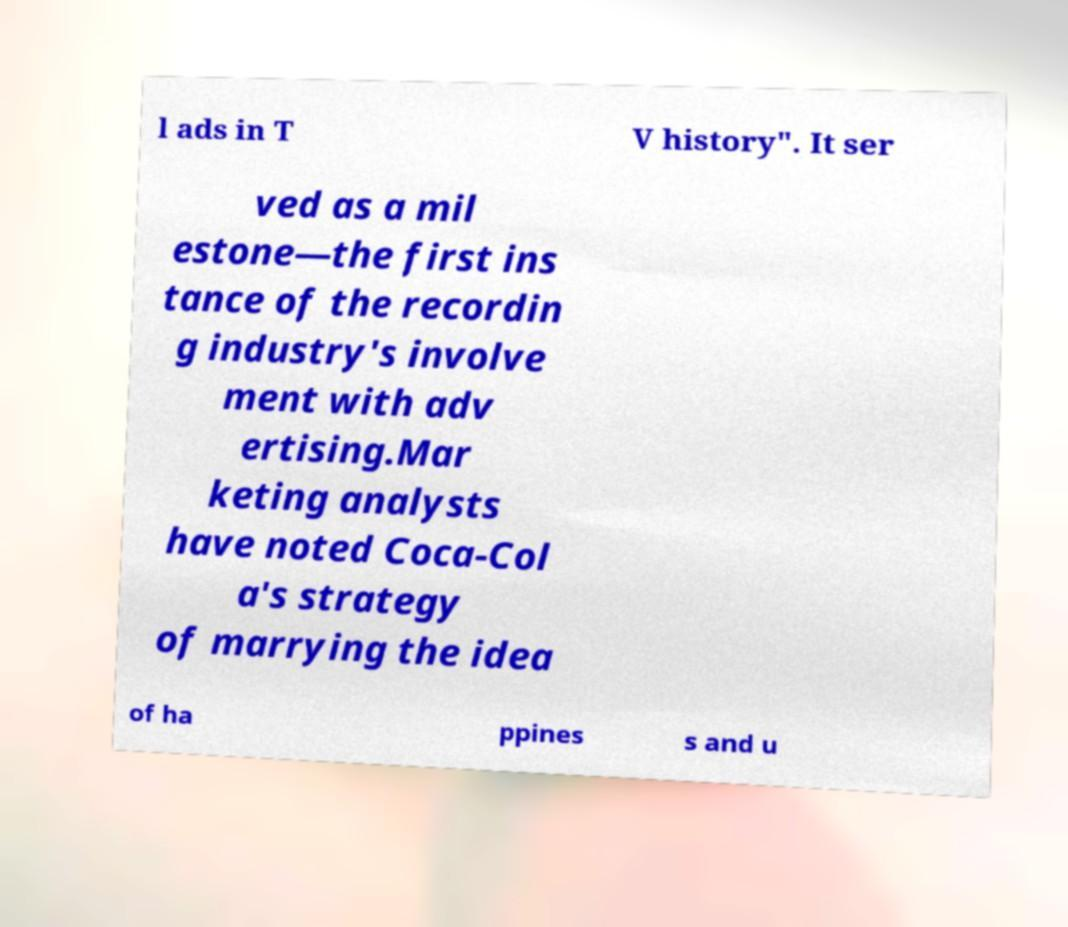There's text embedded in this image that I need extracted. Can you transcribe it verbatim? l ads in T V history". It ser ved as a mil estone—the first ins tance of the recordin g industry's involve ment with adv ertising.Mar keting analysts have noted Coca-Col a's strategy of marrying the idea of ha ppines s and u 